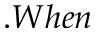Convert formula to latex. <formula><loc_0><loc_0><loc_500><loc_500>. W h e n</formula> 